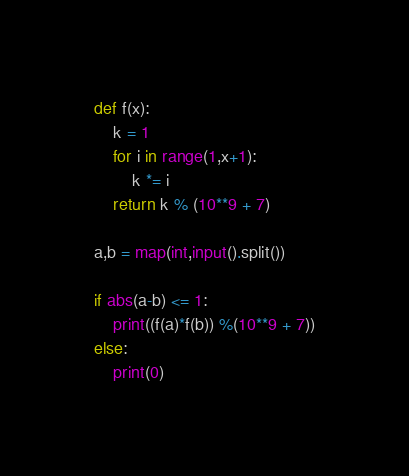Convert code to text. <code><loc_0><loc_0><loc_500><loc_500><_Python_>def f(x):
    k = 1
    for i in range(1,x+1):
        k *= i
    return k % (10**9 + 7)

a,b = map(int,input().split())

if abs(a-b) <= 1:
    print((f(a)*f(b)) %(10**9 + 7))
else:
    print(0)</code> 